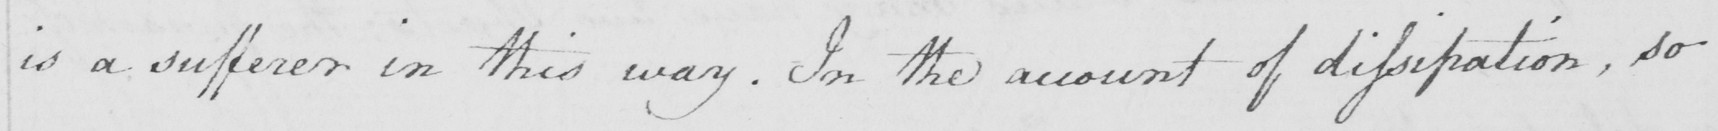Please transcribe the handwritten text in this image. is a sufferer in this way . In the account of dissipation , so 